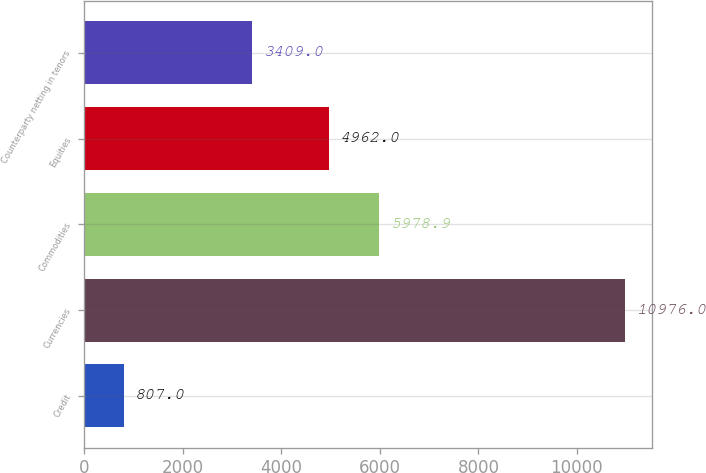Convert chart. <chart><loc_0><loc_0><loc_500><loc_500><bar_chart><fcel>Credit<fcel>Currencies<fcel>Commodities<fcel>Equities<fcel>Counterparty netting in tenors<nl><fcel>807<fcel>10976<fcel>5978.9<fcel>4962<fcel>3409<nl></chart> 